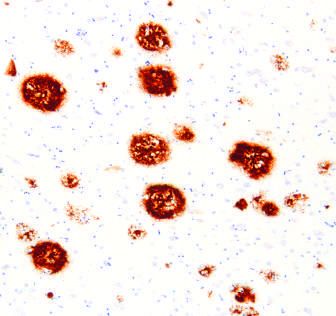where is peptide present in?
Answer the question using a single word or phrase. The core of the plaques as well as the surrounding region 